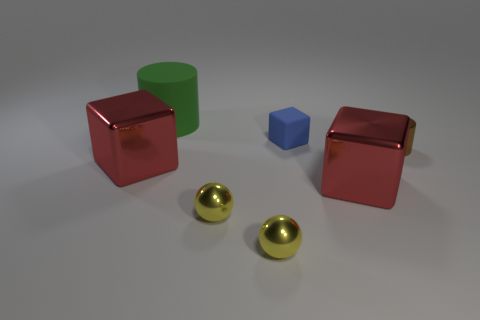Subtract all green cylinders. Subtract all cyan blocks. How many cylinders are left? 1 Add 2 tiny gray rubber spheres. How many objects exist? 9 Subtract all spheres. How many objects are left? 5 Subtract 1 red cubes. How many objects are left? 6 Subtract all brown metallic spheres. Subtract all large blocks. How many objects are left? 5 Add 2 big green cylinders. How many big green cylinders are left? 3 Add 2 big green objects. How many big green objects exist? 3 